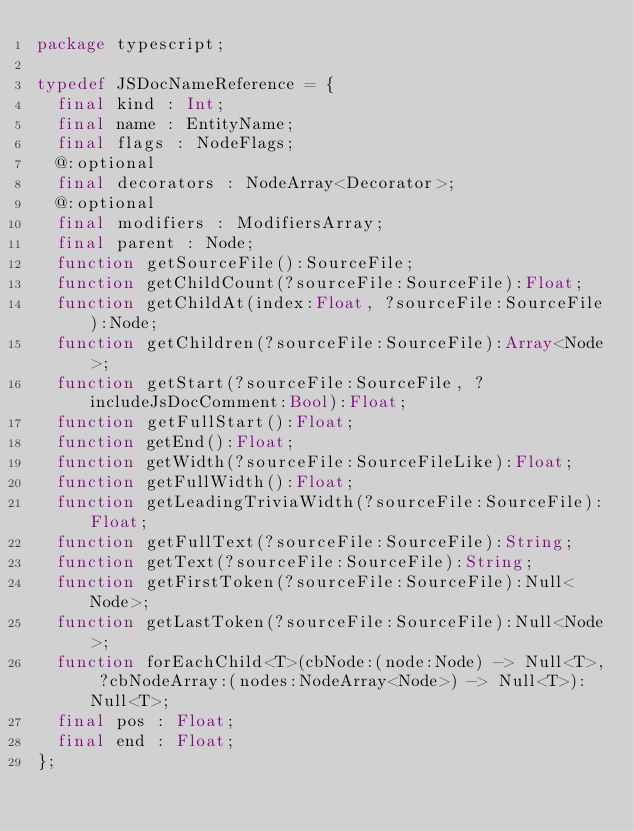Convert code to text. <code><loc_0><loc_0><loc_500><loc_500><_Haxe_>package typescript;

typedef JSDocNameReference = {
	final kind : Int;
	final name : EntityName;
	final flags : NodeFlags;
	@:optional
	final decorators : NodeArray<Decorator>;
	@:optional
	final modifiers : ModifiersArray;
	final parent : Node;
	function getSourceFile():SourceFile;
	function getChildCount(?sourceFile:SourceFile):Float;
	function getChildAt(index:Float, ?sourceFile:SourceFile):Node;
	function getChildren(?sourceFile:SourceFile):Array<Node>;
	function getStart(?sourceFile:SourceFile, ?includeJsDocComment:Bool):Float;
	function getFullStart():Float;
	function getEnd():Float;
	function getWidth(?sourceFile:SourceFileLike):Float;
	function getFullWidth():Float;
	function getLeadingTriviaWidth(?sourceFile:SourceFile):Float;
	function getFullText(?sourceFile:SourceFile):String;
	function getText(?sourceFile:SourceFile):String;
	function getFirstToken(?sourceFile:SourceFile):Null<Node>;
	function getLastToken(?sourceFile:SourceFile):Null<Node>;
	function forEachChild<T>(cbNode:(node:Node) -> Null<T>, ?cbNodeArray:(nodes:NodeArray<Node>) -> Null<T>):Null<T>;
	final pos : Float;
	final end : Float;
};</code> 